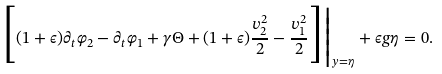<formula> <loc_0><loc_0><loc_500><loc_500>\Big [ ( 1 + \epsilon ) \partial _ { t } \varphi _ { 2 } - \partial _ { t } \varphi _ { 1 } + \gamma \Theta + ( 1 + \epsilon ) \frac { { v } _ { 2 } ^ { 2 } } { 2 } - \frac { { v } _ { 1 } ^ { 2 } } { 2 } \Big ] \Big | _ { y = \eta } + \epsilon g \eta = 0 .</formula> 